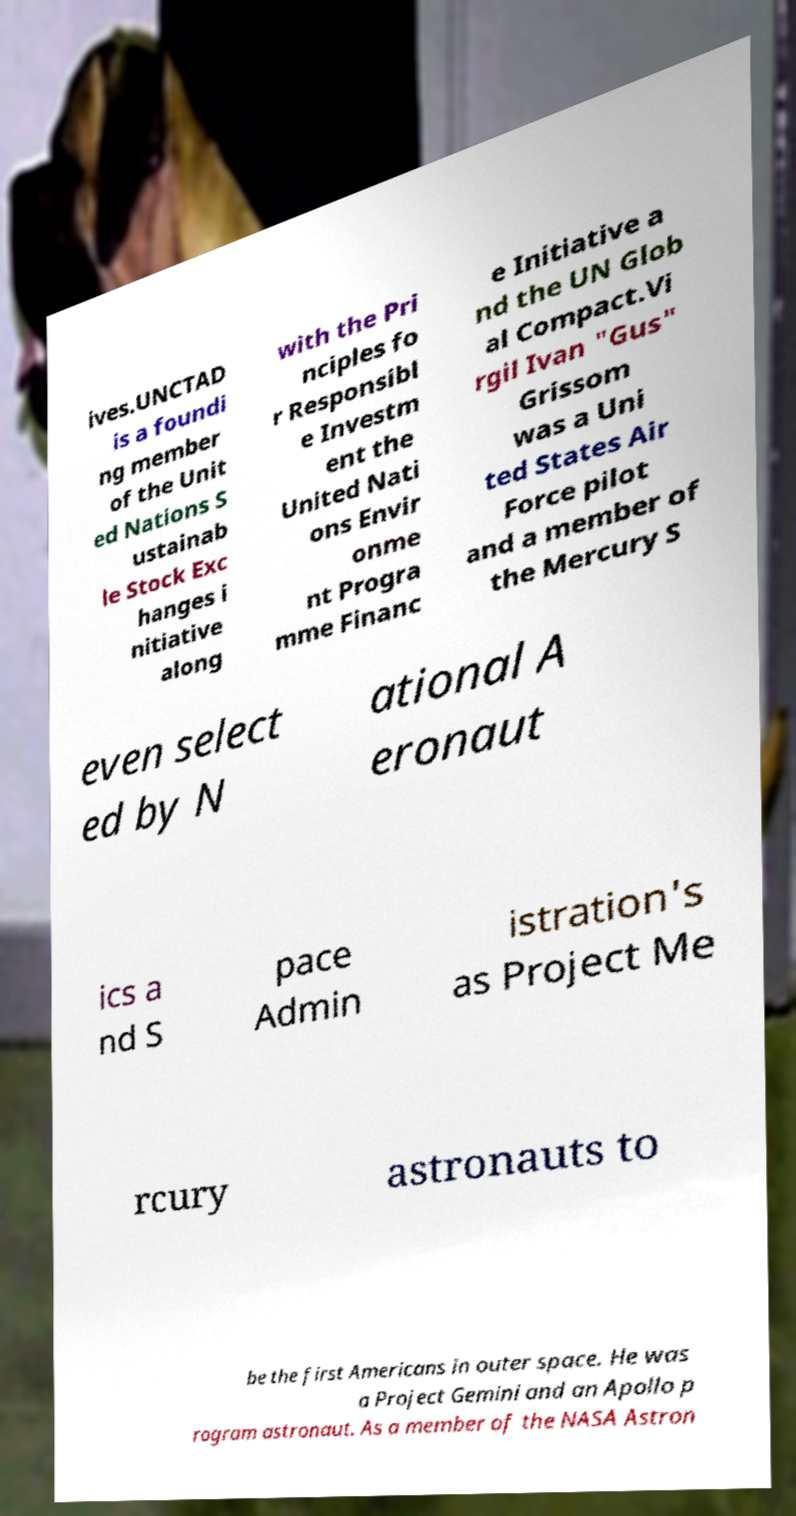There's text embedded in this image that I need extracted. Can you transcribe it verbatim? ives.UNCTAD is a foundi ng member of the Unit ed Nations S ustainab le Stock Exc hanges i nitiative along with the Pri nciples fo r Responsibl e Investm ent the United Nati ons Envir onme nt Progra mme Financ e Initiative a nd the UN Glob al Compact.Vi rgil Ivan "Gus" Grissom was a Uni ted States Air Force pilot and a member of the Mercury S even select ed by N ational A eronaut ics a nd S pace Admin istration's as Project Me rcury astronauts to be the first Americans in outer space. He was a Project Gemini and an Apollo p rogram astronaut. As a member of the NASA Astron 